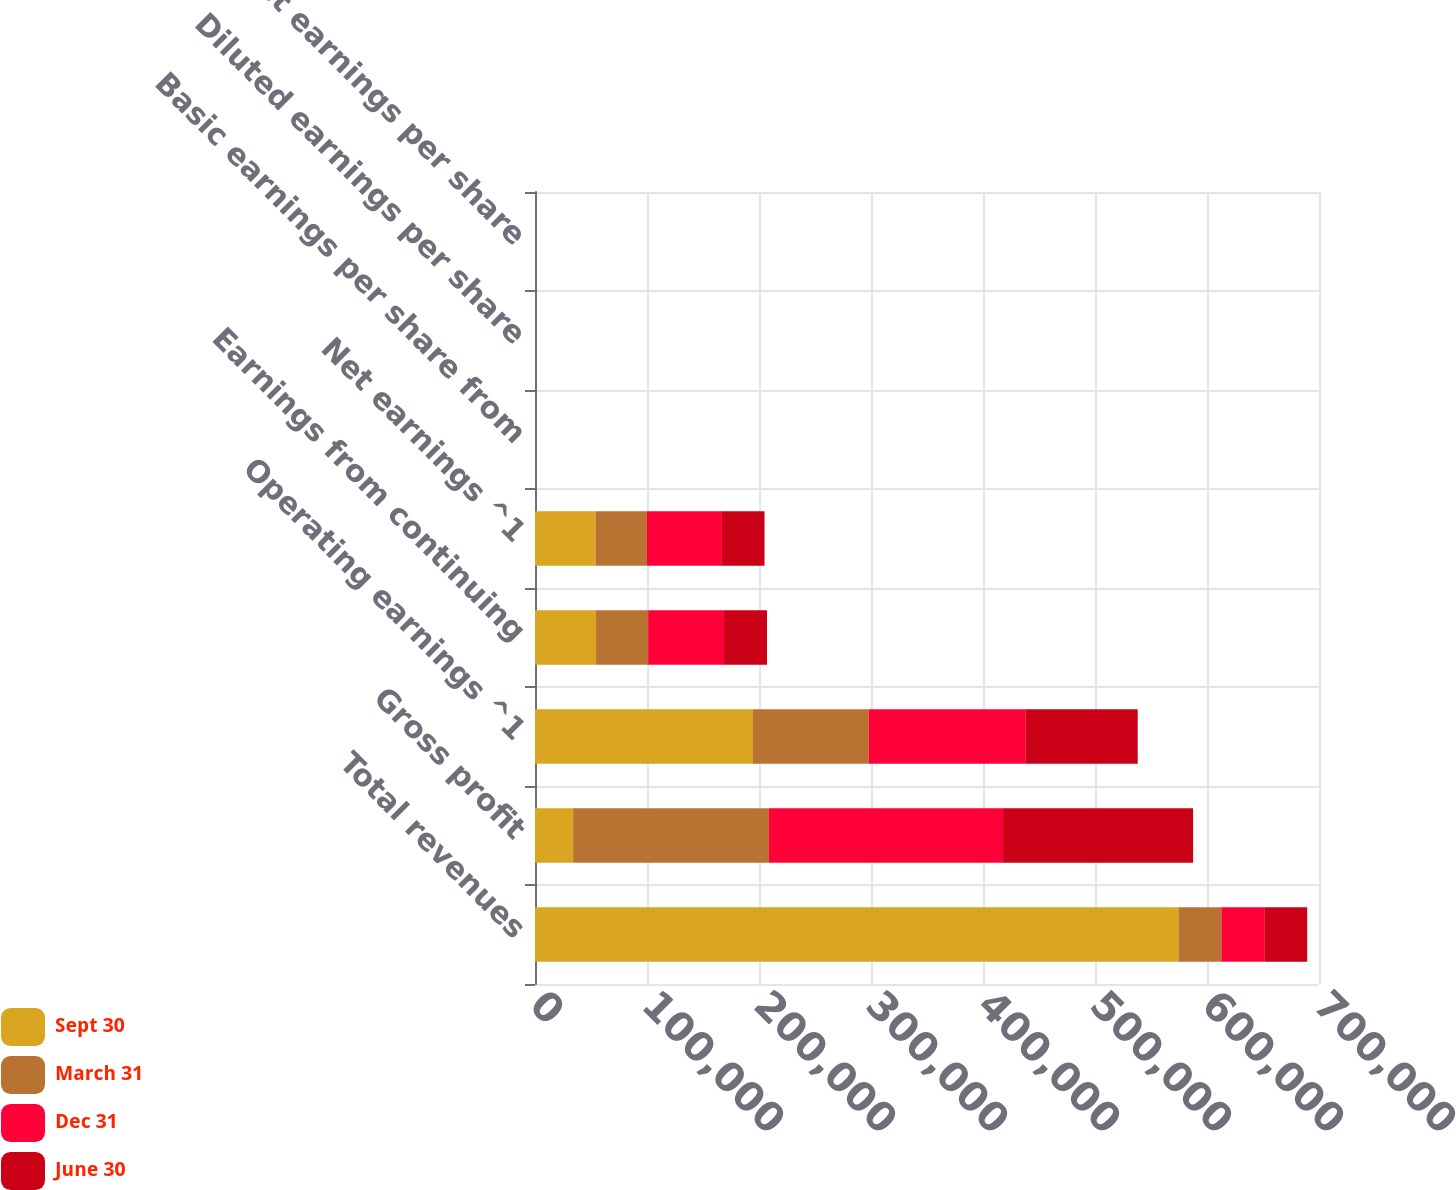Convert chart to OTSL. <chart><loc_0><loc_0><loc_500><loc_500><stacked_bar_chart><ecel><fcel>Total revenues<fcel>Gross profit<fcel>Operating earnings ^1<fcel>Earnings from continuing<fcel>Net earnings ^1<fcel>Basic earnings per share from<fcel>Diluted earnings per share<fcel>Basic net earnings per share<nl><fcel>Sept 30<fcel>574420<fcel>34092<fcel>194669<fcel>54505<fcel>53995<fcel>0.42<fcel>0.41<fcel>0.41<nl><fcel>March 31<fcel>38349<fcel>174788<fcel>103246<fcel>46511<fcel>45967<fcel>0.35<fcel>0.35<fcel>0.35<nl><fcel>Dec 31<fcel>38349<fcel>209042<fcel>140331<fcel>67781<fcel>66939<fcel>0.51<fcel>0.51<fcel>0.51<nl><fcel>June 30<fcel>38349<fcel>169660<fcel>99892<fcel>38349<fcel>38022<fcel>0.29<fcel>0.29<fcel>0.29<nl></chart> 